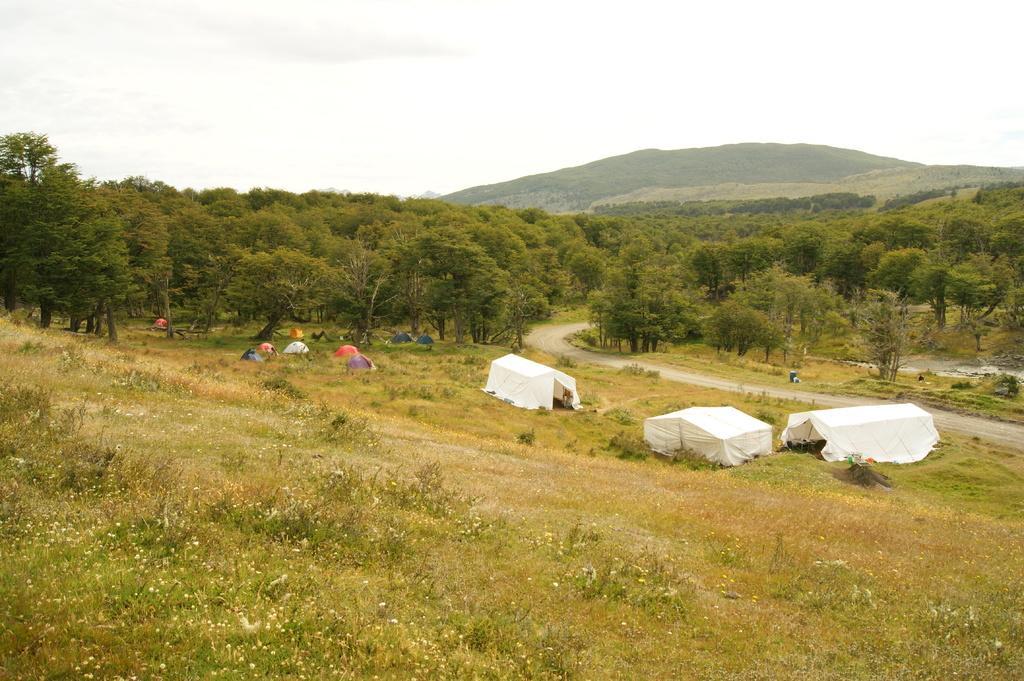Please provide a concise description of this image. In this image we can see some tents on the ground. In the foreground of the image we can see some plants and grass. In the center of the image we can see a group of trees. On the right side of the image we can see hills. At the top of the image we can see the sky. 